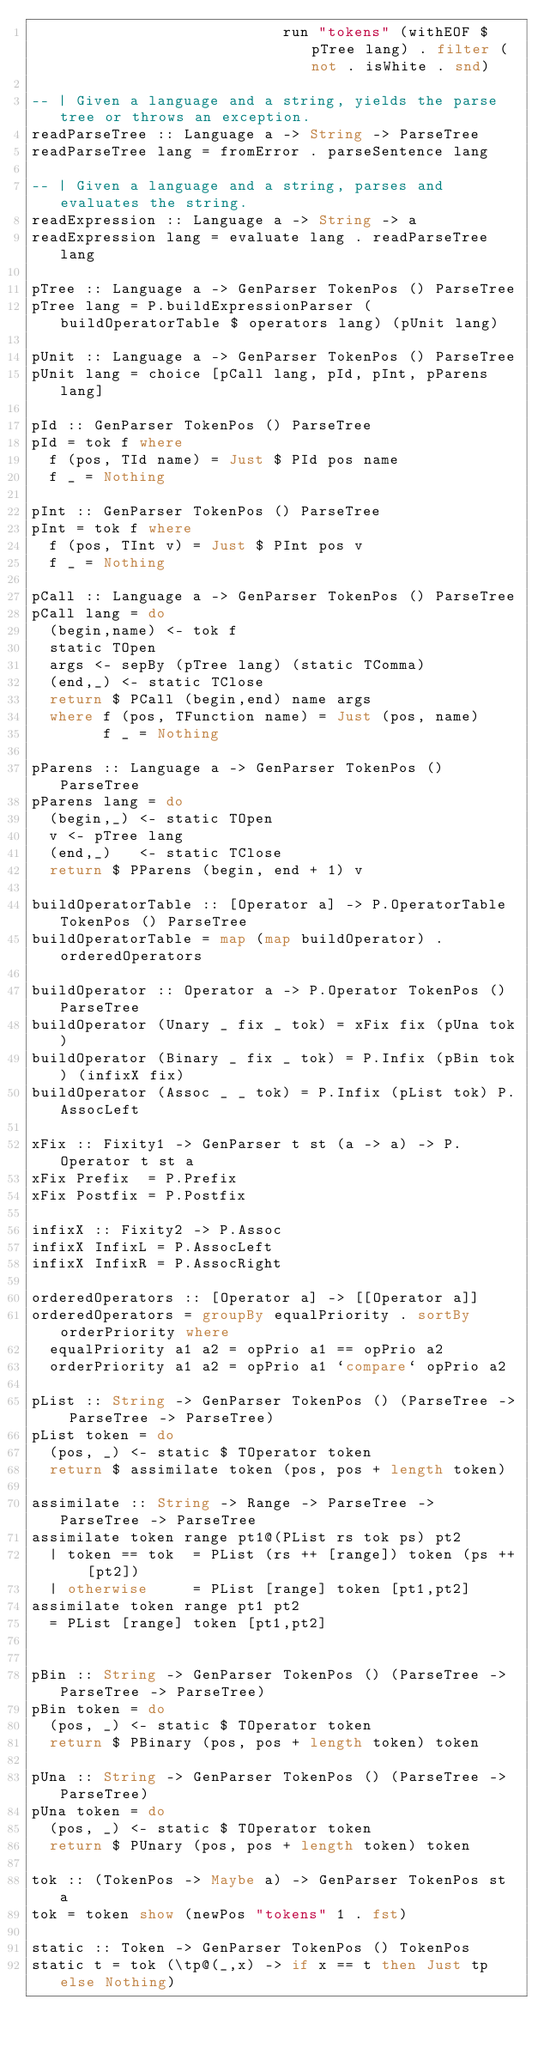<code> <loc_0><loc_0><loc_500><loc_500><_Haskell_>                            run "tokens" (withEOF $ pTree lang) . filter (not . isWhite . snd)

-- | Given a language and a string, yields the parse tree or throws an exception.
readParseTree :: Language a -> String -> ParseTree
readParseTree lang = fromError . parseSentence lang

-- | Given a language and a string, parses and evaluates the string.
readExpression :: Language a -> String -> a
readExpression lang = evaluate lang . readParseTree lang

pTree :: Language a -> GenParser TokenPos () ParseTree
pTree lang = P.buildExpressionParser (buildOperatorTable $ operators lang) (pUnit lang)

pUnit :: Language a -> GenParser TokenPos () ParseTree
pUnit lang = choice [pCall lang, pId, pInt, pParens lang]

pId :: GenParser TokenPos () ParseTree
pId = tok f where
  f (pos, TId name) = Just $ PId pos name
  f _ = Nothing

pInt :: GenParser TokenPos () ParseTree
pInt = tok f where
  f (pos, TInt v) = Just $ PInt pos v
  f _ = Nothing

pCall :: Language a -> GenParser TokenPos () ParseTree
pCall lang = do
  (begin,name) <- tok f
  static TOpen
  args <- sepBy (pTree lang) (static TComma)
  (end,_) <- static TClose
  return $ PCall (begin,end) name args
  where f (pos, TFunction name) = Just (pos, name)
        f _ = Nothing

pParens :: Language a -> GenParser TokenPos () ParseTree
pParens lang = do
  (begin,_) <- static TOpen
  v <- pTree lang
  (end,_)   <- static TClose
  return $ PParens (begin, end + 1) v

buildOperatorTable :: [Operator a] -> P.OperatorTable TokenPos () ParseTree
buildOperatorTable = map (map buildOperator) . orderedOperators

buildOperator :: Operator a -> P.Operator TokenPos () ParseTree
buildOperator (Unary _ fix _ tok) = xFix fix (pUna tok)
buildOperator (Binary _ fix _ tok) = P.Infix (pBin tok) (infixX fix)
buildOperator (Assoc _ _ tok) = P.Infix (pList tok) P.AssocLeft

xFix :: Fixity1 -> GenParser t st (a -> a) -> P.Operator t st a
xFix Prefix  = P.Prefix
xFix Postfix = P.Postfix

infixX :: Fixity2 -> P.Assoc
infixX InfixL = P.AssocLeft
infixX InfixR = P.AssocRight

orderedOperators :: [Operator a] -> [[Operator a]]
orderedOperators = groupBy equalPriority . sortBy orderPriority where
  equalPriority a1 a2 = opPrio a1 == opPrio a2
  orderPriority a1 a2 = opPrio a1 `compare` opPrio a2

pList :: String -> GenParser TokenPos () (ParseTree -> ParseTree -> ParseTree)
pList token = do
  (pos, _) <- static $ TOperator token
  return $ assimilate token (pos, pos + length token)

assimilate :: String -> Range -> ParseTree -> ParseTree -> ParseTree
assimilate token range pt1@(PList rs tok ps) pt2
  | token == tok  = PList (rs ++ [range]) token (ps ++ [pt2])
  | otherwise     = PList [range] token [pt1,pt2]
assimilate token range pt1 pt2
  = PList [range] token [pt1,pt2]


pBin :: String -> GenParser TokenPos () (ParseTree -> ParseTree -> ParseTree)
pBin token = do
  (pos, _) <- static $ TOperator token
  return $ PBinary (pos, pos + length token) token

pUna :: String -> GenParser TokenPos () (ParseTree -> ParseTree)
pUna token = do
  (pos, _) <- static $ TOperator token
  return $ PUnary (pos, pos + length token) token

tok :: (TokenPos -> Maybe a) -> GenParser TokenPos st a
tok = token show (newPos "tokens" 1 . fst)

static :: Token -> GenParser TokenPos () TokenPos
static t = tok (\tp@(_,x) -> if x == t then Just tp else Nothing)
</code> 